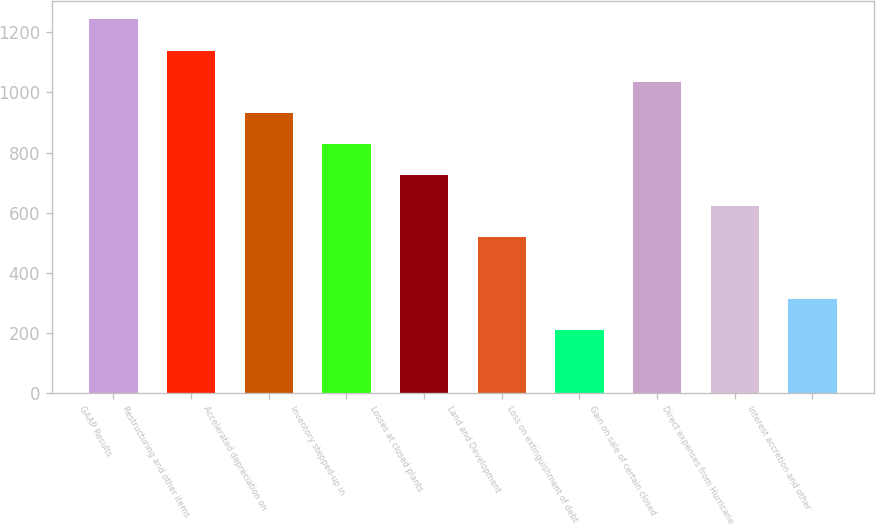Convert chart. <chart><loc_0><loc_0><loc_500><loc_500><bar_chart><fcel>GAAP Results<fcel>Restructuring and other items<fcel>Accelerated depreciation on<fcel>Inventory stepped-up in<fcel>Losses at closed plants<fcel>Land and Development<fcel>Loss on extinguishment of debt<fcel>Gain on sale of certain closed<fcel>Direct expenses from Hurricane<fcel>Interest accretion and other<nl><fcel>1242.5<fcel>1139.2<fcel>932.6<fcel>829.3<fcel>726<fcel>519.4<fcel>209.5<fcel>1035.9<fcel>622.7<fcel>312.8<nl></chart> 